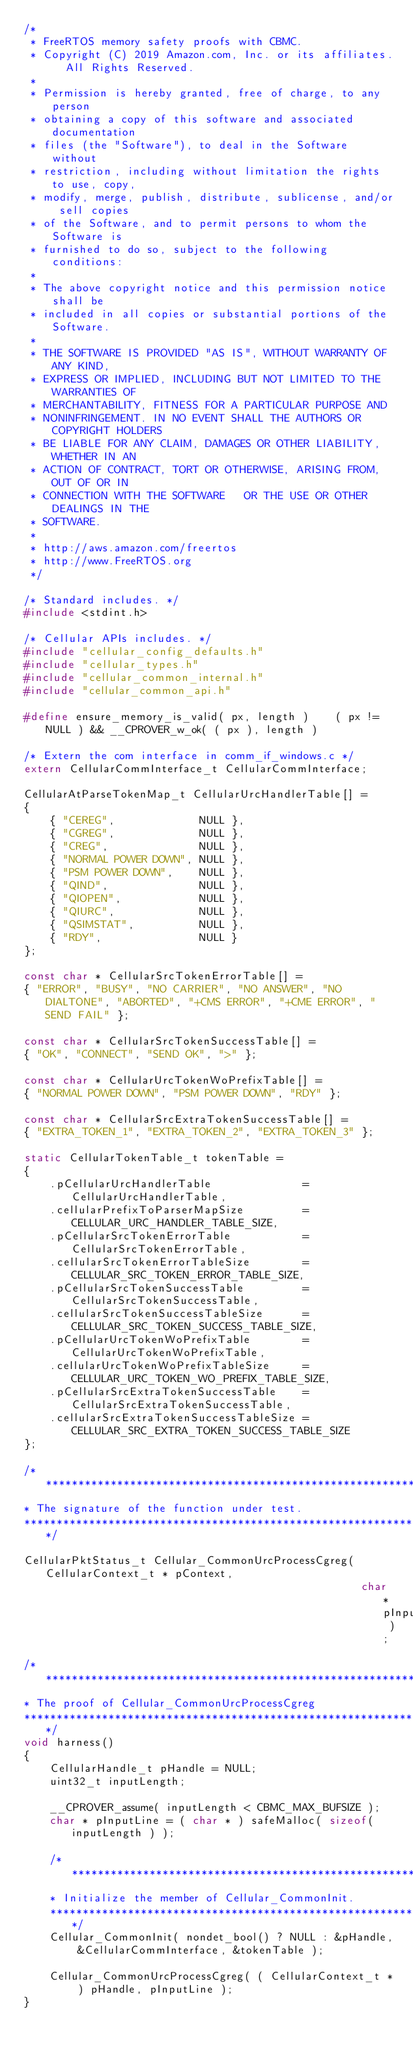<code> <loc_0><loc_0><loc_500><loc_500><_C_>/*
 * FreeRTOS memory safety proofs with CBMC.
 * Copyright (C) 2019 Amazon.com, Inc. or its affiliates.  All Rights Reserved.
 *
 * Permission is hereby granted, free of charge, to any person
 * obtaining a copy of this software and associated documentation
 * files (the "Software"), to deal in the Software without
 * restriction, including without limitation the rights to use, copy,
 * modify, merge, publish, distribute, sublicense, and/or sell copies
 * of the Software, and to permit persons to whom the Software is
 * furnished to do so, subject to the following conditions:
 *
 * The above copyright notice and this permission notice shall be
 * included in all copies or substantial portions of the Software.
 *
 * THE SOFTWARE IS PROVIDED "AS IS", WITHOUT WARRANTY OF ANY KIND,
 * EXPRESS OR IMPLIED, INCLUDING BUT NOT LIMITED TO THE WARRANTIES OF
 * MERCHANTABILITY, FITNESS FOR A PARTICULAR PURPOSE AND
 * NONINFRINGEMENT. IN NO EVENT SHALL THE AUTHORS OR COPYRIGHT HOLDERS
 * BE LIABLE FOR ANY CLAIM, DAMAGES OR OTHER LIABILITY, WHETHER IN AN
 * ACTION OF CONTRACT, TORT OR OTHERWISE, ARISING FROM, OUT OF OR IN
 * CONNECTION WITH THE SOFTWARE   OR THE USE OR OTHER DEALINGS IN THE
 * SOFTWARE.
 *
 * http://aws.amazon.com/freertos
 * http://www.FreeRTOS.org
 */

/* Standard includes. */
#include <stdint.h>

/* Cellular APIs includes. */
#include "cellular_config_defaults.h"
#include "cellular_types.h"
#include "cellular_common_internal.h"
#include "cellular_common_api.h"

#define ensure_memory_is_valid( px, length )    ( px != NULL ) && __CPROVER_w_ok( ( px ), length )

/* Extern the com interface in comm_if_windows.c */
extern CellularCommInterface_t CellularCommInterface;

CellularAtParseTokenMap_t CellularUrcHandlerTable[] =
{
    { "CEREG",             NULL },
    { "CGREG",             NULL },
    { "CREG",              NULL },
    { "NORMAL POWER DOWN", NULL },
    { "PSM POWER DOWN",    NULL },
    { "QIND",              NULL },
    { "QIOPEN",            NULL },
    { "QIURC",             NULL },
    { "QSIMSTAT",          NULL },
    { "RDY",               NULL }
};

const char * CellularSrcTokenErrorTable[] =
{ "ERROR", "BUSY", "NO CARRIER", "NO ANSWER", "NO DIALTONE", "ABORTED", "+CMS ERROR", "+CME ERROR", "SEND FAIL" };

const char * CellularSrcTokenSuccessTable[] =
{ "OK", "CONNECT", "SEND OK", ">" };

const char * CellularUrcTokenWoPrefixTable[] =
{ "NORMAL POWER DOWN", "PSM POWER DOWN", "RDY" };

const char * CellularSrcExtraTokenSuccessTable[] =
{ "EXTRA_TOKEN_1", "EXTRA_TOKEN_2", "EXTRA_TOKEN_3" };

static CellularTokenTable_t tokenTable =
{
    .pCellularUrcHandlerTable              = CellularUrcHandlerTable,
    .cellularPrefixToParserMapSize         = CELLULAR_URC_HANDLER_TABLE_SIZE,
    .pCellularSrcTokenErrorTable           = CellularSrcTokenErrorTable,
    .cellularSrcTokenErrorTableSize        = CELLULAR_SRC_TOKEN_ERROR_TABLE_SIZE,
    .pCellularSrcTokenSuccessTable         = CellularSrcTokenSuccessTable,
    .cellularSrcTokenSuccessTableSize      = CELLULAR_SRC_TOKEN_SUCCESS_TABLE_SIZE,
    .pCellularUrcTokenWoPrefixTable        = CellularUrcTokenWoPrefixTable,
    .cellularUrcTokenWoPrefixTableSize     = CELLULAR_URC_TOKEN_WO_PREFIX_TABLE_SIZE,
    .pCellularSrcExtraTokenSuccessTable    = CellularSrcExtraTokenSuccessTable,
    .cellularSrcExtraTokenSuccessTableSize = CELLULAR_SRC_EXTRA_TOKEN_SUCCESS_TABLE_SIZE
};

/****************************************************************
* The signature of the function under test.
****************************************************************/

CellularPktStatus_t Cellular_CommonUrcProcessCgreg( CellularContext_t * pContext,
                                                    char * pInputLine );

/****************************************************************
* The proof of Cellular_CommonUrcProcessCgreg
****************************************************************/
void harness()
{
    CellularHandle_t pHandle = NULL;
    uint32_t inputLength;

    __CPROVER_assume( inputLength < CBMC_MAX_BUFSIZE );
    char * pInputLine = ( char * ) safeMalloc( sizeof( inputLength ) );

    /****************************************************************
    * Initialize the member of Cellular_CommonInit.
    ****************************************************************/
    Cellular_CommonInit( nondet_bool() ? NULL : &pHandle, &CellularCommInterface, &tokenTable );

    Cellular_CommonUrcProcessCgreg( ( CellularContext_t * ) pHandle, pInputLine );
}
</code> 